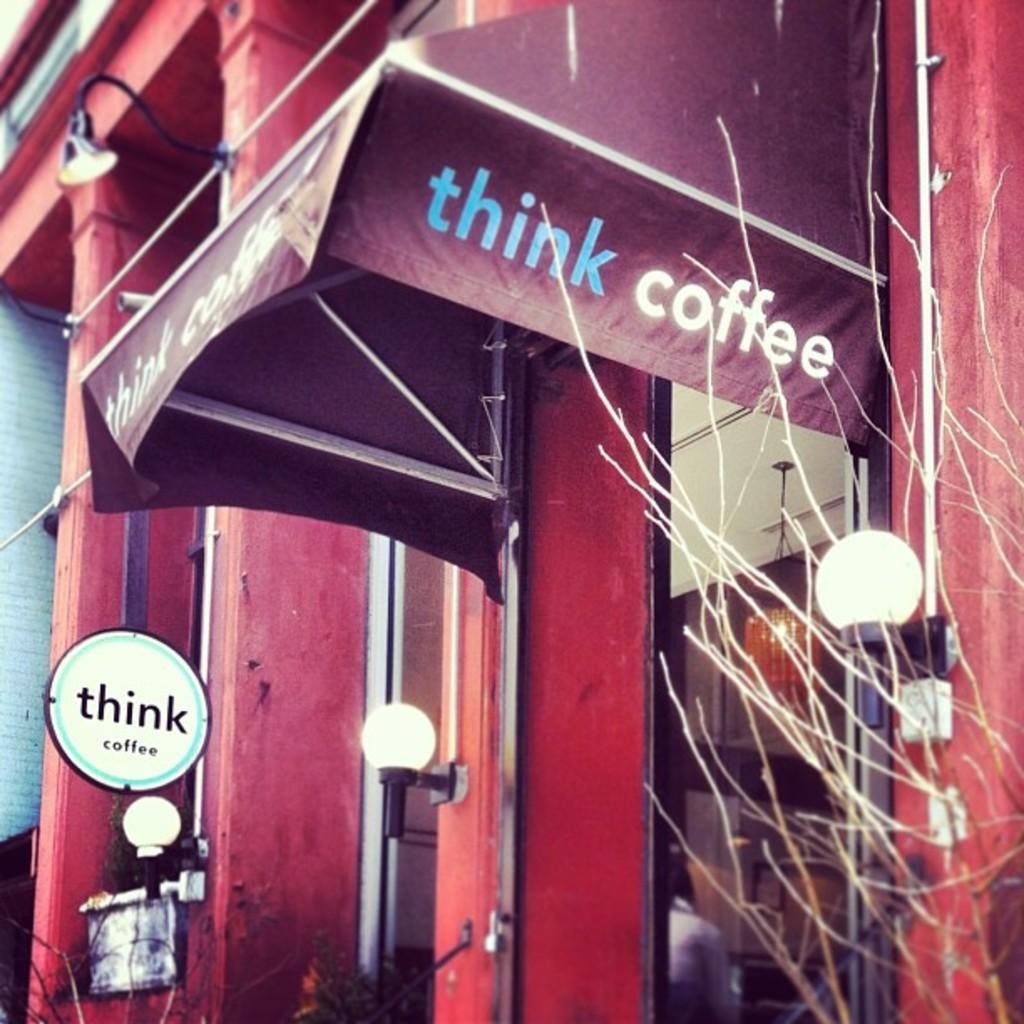What is the main structure visible in the image? There is a building in the image. Are there any additional features associated with the building? Yes, the building has lights in front of it. What type of lunch is being served in the building in the image? There is no information about lunch or any food being served in the image. 